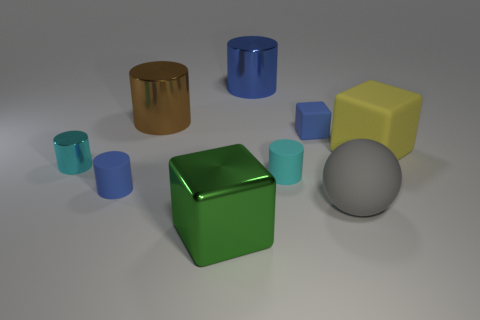Add 1 gray rubber cylinders. How many objects exist? 10 Subtract all cylinders. How many objects are left? 4 Subtract all brown cylinders. How many cylinders are left? 4 Subtract all blue cylinders. How many cylinders are left? 3 Subtract 0 gray cylinders. How many objects are left? 9 Subtract 1 spheres. How many spheres are left? 0 Subtract all blue blocks. Subtract all blue cylinders. How many blocks are left? 2 Subtract all gray cylinders. How many yellow blocks are left? 1 Subtract all big matte cubes. Subtract all blocks. How many objects are left? 5 Add 4 cyan shiny cylinders. How many cyan shiny cylinders are left? 5 